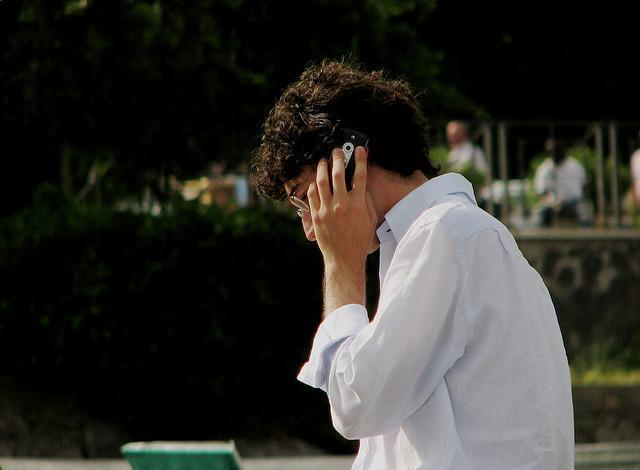How many people can you see?
Give a very brief answer. 2. How many cat tails are visible in the image?
Give a very brief answer. 0. 